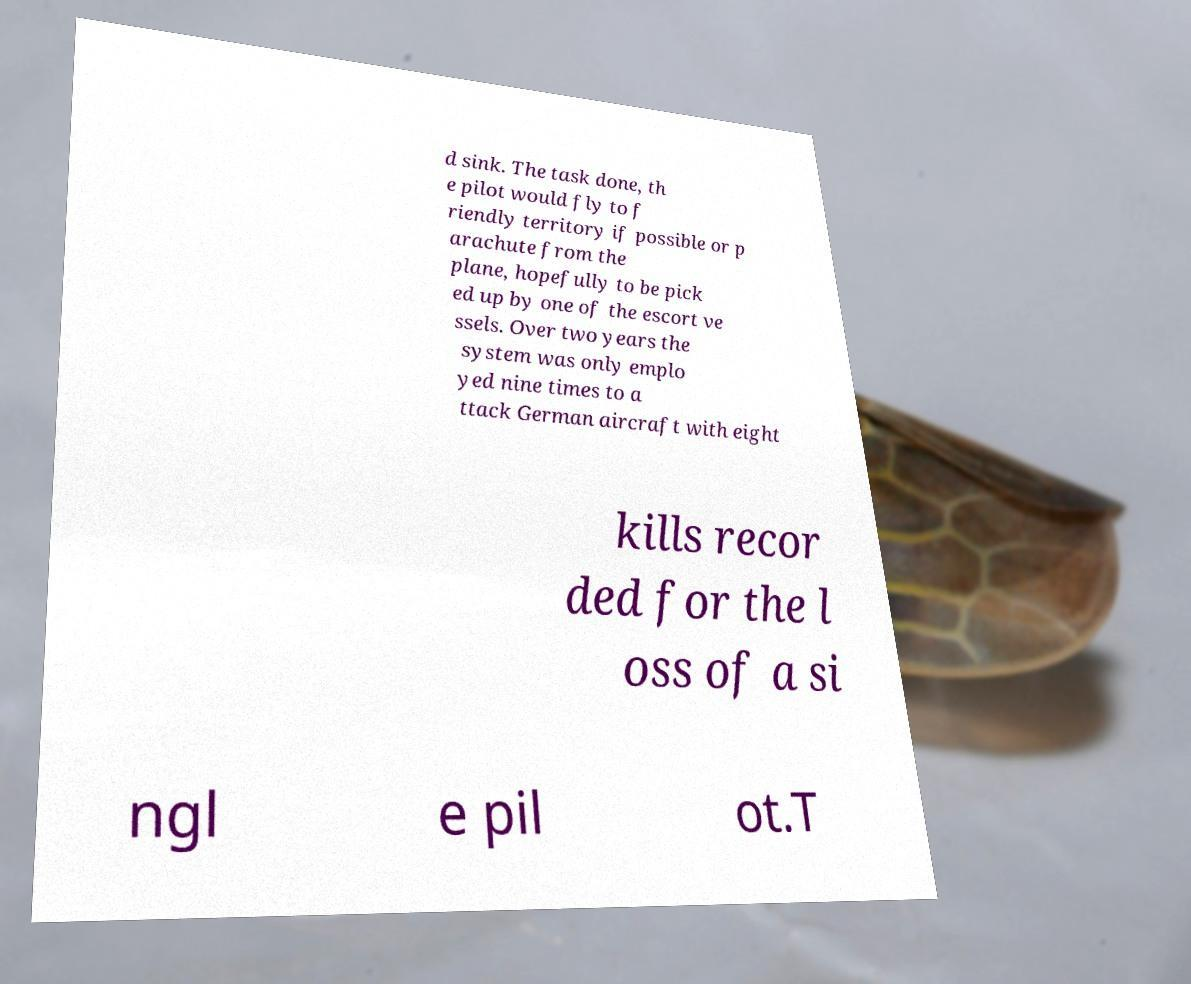Can you accurately transcribe the text from the provided image for me? d sink. The task done, th e pilot would fly to f riendly territory if possible or p arachute from the plane, hopefully to be pick ed up by one of the escort ve ssels. Over two years the system was only emplo yed nine times to a ttack German aircraft with eight kills recor ded for the l oss of a si ngl e pil ot.T 